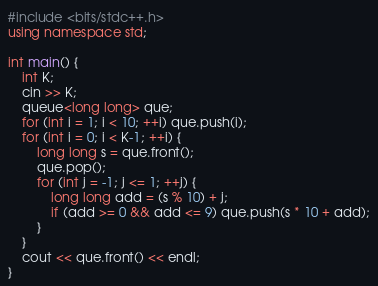<code> <loc_0><loc_0><loc_500><loc_500><_C++_>#include <bits/stdc++.h>
using namespace std;

int main() {
    int K;
    cin >> K;
    queue<long long> que;
    for (int i = 1; i < 10; ++i) que.push(i);
    for (int i = 0; i < K-1; ++i) {
        long long s = que.front();
        que.pop();
        for (int j = -1; j <= 1; ++j) {
            long long add = (s % 10) + j;
            if (add >= 0 && add <= 9) que.push(s * 10 + add);
        }
    }
    cout << que.front() << endl;
}</code> 